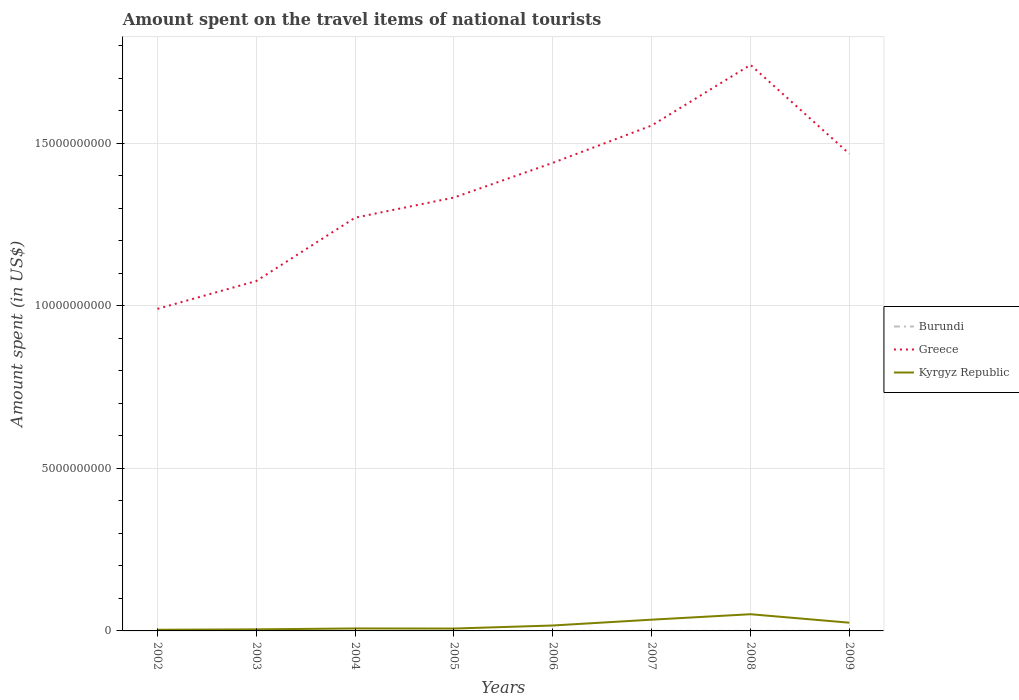Does the line corresponding to Kyrgyz Republic intersect with the line corresponding to Burundi?
Keep it short and to the point. No. Across all years, what is the maximum amount spent on the travel items of national tourists in Greece?
Your answer should be compact. 9.91e+09. In which year was the amount spent on the travel items of national tourists in Burundi maximum?
Your answer should be very brief. 2003. What is the total amount spent on the travel items of national tourists in Kyrgyz Republic in the graph?
Your response must be concise. 9.30e+07. What is the difference between the highest and the second highest amount spent on the travel items of national tourists in Burundi?
Offer a very short reply. 8.00e+05. Is the amount spent on the travel items of national tourists in Kyrgyz Republic strictly greater than the amount spent on the travel items of national tourists in Greece over the years?
Give a very brief answer. Yes. How many years are there in the graph?
Your answer should be compact. 8. Does the graph contain any zero values?
Provide a short and direct response. No. How are the legend labels stacked?
Make the answer very short. Vertical. What is the title of the graph?
Keep it short and to the point. Amount spent on the travel items of national tourists. Does "Cameroon" appear as one of the legend labels in the graph?
Give a very brief answer. No. What is the label or title of the X-axis?
Your answer should be very brief. Years. What is the label or title of the Y-axis?
Your response must be concise. Amount spent (in US$). What is the Amount spent (in US$) of Burundi in 2002?
Give a very brief answer. 1.10e+06. What is the Amount spent (in US$) in Greece in 2002?
Ensure brevity in your answer.  9.91e+09. What is the Amount spent (in US$) in Kyrgyz Republic in 2002?
Keep it short and to the point. 3.60e+07. What is the Amount spent (in US$) of Greece in 2003?
Provide a short and direct response. 1.08e+1. What is the Amount spent (in US$) of Kyrgyz Republic in 2003?
Offer a terse response. 4.80e+07. What is the Amount spent (in US$) of Burundi in 2004?
Your answer should be very brief. 1.20e+06. What is the Amount spent (in US$) of Greece in 2004?
Provide a short and direct response. 1.27e+1. What is the Amount spent (in US$) in Kyrgyz Republic in 2004?
Provide a succinct answer. 7.60e+07. What is the Amount spent (in US$) of Burundi in 2005?
Make the answer very short. 1.50e+06. What is the Amount spent (in US$) in Greece in 2005?
Your answer should be compact. 1.33e+1. What is the Amount spent (in US$) in Kyrgyz Republic in 2005?
Your response must be concise. 7.30e+07. What is the Amount spent (in US$) of Burundi in 2006?
Ensure brevity in your answer.  1.30e+06. What is the Amount spent (in US$) of Greece in 2006?
Give a very brief answer. 1.44e+1. What is the Amount spent (in US$) of Kyrgyz Republic in 2006?
Ensure brevity in your answer.  1.67e+08. What is the Amount spent (in US$) of Burundi in 2007?
Give a very brief answer. 1.30e+06. What is the Amount spent (in US$) of Greece in 2007?
Offer a very short reply. 1.56e+1. What is the Amount spent (in US$) of Kyrgyz Republic in 2007?
Offer a very short reply. 3.46e+08. What is the Amount spent (in US$) in Burundi in 2008?
Offer a terse response. 1.30e+06. What is the Amount spent (in US$) of Greece in 2008?
Make the answer very short. 1.74e+1. What is the Amount spent (in US$) of Kyrgyz Republic in 2008?
Your answer should be compact. 5.14e+08. What is the Amount spent (in US$) in Burundi in 2009?
Provide a succinct answer. 1.50e+06. What is the Amount spent (in US$) in Greece in 2009?
Ensure brevity in your answer.  1.47e+1. What is the Amount spent (in US$) of Kyrgyz Republic in 2009?
Make the answer very short. 2.53e+08. Across all years, what is the maximum Amount spent (in US$) of Burundi?
Offer a terse response. 1.50e+06. Across all years, what is the maximum Amount spent (in US$) of Greece?
Your answer should be compact. 1.74e+1. Across all years, what is the maximum Amount spent (in US$) in Kyrgyz Republic?
Offer a terse response. 5.14e+08. Across all years, what is the minimum Amount spent (in US$) of Greece?
Your answer should be compact. 9.91e+09. Across all years, what is the minimum Amount spent (in US$) in Kyrgyz Republic?
Your answer should be compact. 3.60e+07. What is the total Amount spent (in US$) of Burundi in the graph?
Offer a very short reply. 9.90e+06. What is the total Amount spent (in US$) of Greece in the graph?
Keep it short and to the point. 1.09e+11. What is the total Amount spent (in US$) in Kyrgyz Republic in the graph?
Provide a short and direct response. 1.51e+09. What is the difference between the Amount spent (in US$) of Burundi in 2002 and that in 2003?
Your answer should be compact. 4.00e+05. What is the difference between the Amount spent (in US$) of Greece in 2002 and that in 2003?
Provide a short and direct response. -8.57e+08. What is the difference between the Amount spent (in US$) in Kyrgyz Republic in 2002 and that in 2003?
Your answer should be compact. -1.20e+07. What is the difference between the Amount spent (in US$) of Greece in 2002 and that in 2004?
Keep it short and to the point. -2.81e+09. What is the difference between the Amount spent (in US$) in Kyrgyz Republic in 2002 and that in 2004?
Provide a short and direct response. -4.00e+07. What is the difference between the Amount spent (in US$) in Burundi in 2002 and that in 2005?
Keep it short and to the point. -4.00e+05. What is the difference between the Amount spent (in US$) in Greece in 2002 and that in 2005?
Offer a terse response. -3.42e+09. What is the difference between the Amount spent (in US$) of Kyrgyz Republic in 2002 and that in 2005?
Your response must be concise. -3.70e+07. What is the difference between the Amount spent (in US$) in Greece in 2002 and that in 2006?
Your response must be concise. -4.49e+09. What is the difference between the Amount spent (in US$) in Kyrgyz Republic in 2002 and that in 2006?
Provide a short and direct response. -1.31e+08. What is the difference between the Amount spent (in US$) in Greece in 2002 and that in 2007?
Your answer should be compact. -5.64e+09. What is the difference between the Amount spent (in US$) in Kyrgyz Republic in 2002 and that in 2007?
Provide a short and direct response. -3.10e+08. What is the difference between the Amount spent (in US$) of Burundi in 2002 and that in 2008?
Make the answer very short. -2.00e+05. What is the difference between the Amount spent (in US$) of Greece in 2002 and that in 2008?
Ensure brevity in your answer.  -7.51e+09. What is the difference between the Amount spent (in US$) of Kyrgyz Republic in 2002 and that in 2008?
Your response must be concise. -4.78e+08. What is the difference between the Amount spent (in US$) of Burundi in 2002 and that in 2009?
Offer a terse response. -4.00e+05. What is the difference between the Amount spent (in US$) in Greece in 2002 and that in 2009?
Keep it short and to the point. -4.77e+09. What is the difference between the Amount spent (in US$) in Kyrgyz Republic in 2002 and that in 2009?
Your response must be concise. -2.17e+08. What is the difference between the Amount spent (in US$) in Burundi in 2003 and that in 2004?
Offer a terse response. -5.00e+05. What is the difference between the Amount spent (in US$) in Greece in 2003 and that in 2004?
Your response must be concise. -1.95e+09. What is the difference between the Amount spent (in US$) of Kyrgyz Republic in 2003 and that in 2004?
Your response must be concise. -2.80e+07. What is the difference between the Amount spent (in US$) of Burundi in 2003 and that in 2005?
Your response must be concise. -8.00e+05. What is the difference between the Amount spent (in US$) of Greece in 2003 and that in 2005?
Provide a short and direct response. -2.57e+09. What is the difference between the Amount spent (in US$) in Kyrgyz Republic in 2003 and that in 2005?
Provide a succinct answer. -2.50e+07. What is the difference between the Amount spent (in US$) in Burundi in 2003 and that in 2006?
Provide a short and direct response. -6.00e+05. What is the difference between the Amount spent (in US$) of Greece in 2003 and that in 2006?
Give a very brief answer. -3.64e+09. What is the difference between the Amount spent (in US$) in Kyrgyz Republic in 2003 and that in 2006?
Give a very brief answer. -1.19e+08. What is the difference between the Amount spent (in US$) of Burundi in 2003 and that in 2007?
Your answer should be compact. -6.00e+05. What is the difference between the Amount spent (in US$) of Greece in 2003 and that in 2007?
Offer a very short reply. -4.78e+09. What is the difference between the Amount spent (in US$) in Kyrgyz Republic in 2003 and that in 2007?
Make the answer very short. -2.98e+08. What is the difference between the Amount spent (in US$) of Burundi in 2003 and that in 2008?
Your response must be concise. -6.00e+05. What is the difference between the Amount spent (in US$) in Greece in 2003 and that in 2008?
Make the answer very short. -6.65e+09. What is the difference between the Amount spent (in US$) of Kyrgyz Republic in 2003 and that in 2008?
Provide a succinct answer. -4.66e+08. What is the difference between the Amount spent (in US$) in Burundi in 2003 and that in 2009?
Provide a short and direct response. -8.00e+05. What is the difference between the Amount spent (in US$) of Greece in 2003 and that in 2009?
Your response must be concise. -3.92e+09. What is the difference between the Amount spent (in US$) in Kyrgyz Republic in 2003 and that in 2009?
Your answer should be very brief. -2.05e+08. What is the difference between the Amount spent (in US$) in Burundi in 2004 and that in 2005?
Make the answer very short. -3.00e+05. What is the difference between the Amount spent (in US$) of Greece in 2004 and that in 2005?
Make the answer very short. -6.19e+08. What is the difference between the Amount spent (in US$) in Burundi in 2004 and that in 2006?
Provide a short and direct response. -1.00e+05. What is the difference between the Amount spent (in US$) of Greece in 2004 and that in 2006?
Your answer should be compact. -1.69e+09. What is the difference between the Amount spent (in US$) in Kyrgyz Republic in 2004 and that in 2006?
Ensure brevity in your answer.  -9.10e+07. What is the difference between the Amount spent (in US$) of Burundi in 2004 and that in 2007?
Your answer should be compact. -1.00e+05. What is the difference between the Amount spent (in US$) of Greece in 2004 and that in 2007?
Offer a terse response. -2.84e+09. What is the difference between the Amount spent (in US$) of Kyrgyz Republic in 2004 and that in 2007?
Make the answer very short. -2.70e+08. What is the difference between the Amount spent (in US$) of Greece in 2004 and that in 2008?
Your response must be concise. -4.70e+09. What is the difference between the Amount spent (in US$) in Kyrgyz Republic in 2004 and that in 2008?
Your answer should be very brief. -4.38e+08. What is the difference between the Amount spent (in US$) of Greece in 2004 and that in 2009?
Your answer should be compact. -1.97e+09. What is the difference between the Amount spent (in US$) in Kyrgyz Republic in 2004 and that in 2009?
Keep it short and to the point. -1.77e+08. What is the difference between the Amount spent (in US$) in Burundi in 2005 and that in 2006?
Your answer should be compact. 2.00e+05. What is the difference between the Amount spent (in US$) of Greece in 2005 and that in 2006?
Your answer should be very brief. -1.07e+09. What is the difference between the Amount spent (in US$) of Kyrgyz Republic in 2005 and that in 2006?
Give a very brief answer. -9.40e+07. What is the difference between the Amount spent (in US$) in Burundi in 2005 and that in 2007?
Make the answer very short. 2.00e+05. What is the difference between the Amount spent (in US$) of Greece in 2005 and that in 2007?
Your response must be concise. -2.22e+09. What is the difference between the Amount spent (in US$) in Kyrgyz Republic in 2005 and that in 2007?
Give a very brief answer. -2.73e+08. What is the difference between the Amount spent (in US$) in Burundi in 2005 and that in 2008?
Give a very brief answer. 2.00e+05. What is the difference between the Amount spent (in US$) in Greece in 2005 and that in 2008?
Offer a very short reply. -4.08e+09. What is the difference between the Amount spent (in US$) in Kyrgyz Republic in 2005 and that in 2008?
Keep it short and to the point. -4.41e+08. What is the difference between the Amount spent (in US$) in Greece in 2005 and that in 2009?
Your answer should be compact. -1.35e+09. What is the difference between the Amount spent (in US$) in Kyrgyz Republic in 2005 and that in 2009?
Your answer should be very brief. -1.80e+08. What is the difference between the Amount spent (in US$) in Greece in 2006 and that in 2007?
Your answer should be compact. -1.15e+09. What is the difference between the Amount spent (in US$) in Kyrgyz Republic in 2006 and that in 2007?
Ensure brevity in your answer.  -1.79e+08. What is the difference between the Amount spent (in US$) of Burundi in 2006 and that in 2008?
Provide a short and direct response. 0. What is the difference between the Amount spent (in US$) in Greece in 2006 and that in 2008?
Offer a terse response. -3.01e+09. What is the difference between the Amount spent (in US$) of Kyrgyz Republic in 2006 and that in 2008?
Ensure brevity in your answer.  -3.47e+08. What is the difference between the Amount spent (in US$) of Greece in 2006 and that in 2009?
Your response must be concise. -2.79e+08. What is the difference between the Amount spent (in US$) of Kyrgyz Republic in 2006 and that in 2009?
Offer a very short reply. -8.60e+07. What is the difference between the Amount spent (in US$) of Greece in 2007 and that in 2008?
Provide a short and direct response. -1.87e+09. What is the difference between the Amount spent (in US$) in Kyrgyz Republic in 2007 and that in 2008?
Ensure brevity in your answer.  -1.68e+08. What is the difference between the Amount spent (in US$) of Burundi in 2007 and that in 2009?
Offer a very short reply. -2.00e+05. What is the difference between the Amount spent (in US$) in Greece in 2007 and that in 2009?
Your response must be concise. 8.69e+08. What is the difference between the Amount spent (in US$) of Kyrgyz Republic in 2007 and that in 2009?
Your answer should be very brief. 9.30e+07. What is the difference between the Amount spent (in US$) in Burundi in 2008 and that in 2009?
Offer a very short reply. -2.00e+05. What is the difference between the Amount spent (in US$) in Greece in 2008 and that in 2009?
Give a very brief answer. 2.74e+09. What is the difference between the Amount spent (in US$) in Kyrgyz Republic in 2008 and that in 2009?
Make the answer very short. 2.61e+08. What is the difference between the Amount spent (in US$) of Burundi in 2002 and the Amount spent (in US$) of Greece in 2003?
Give a very brief answer. -1.08e+1. What is the difference between the Amount spent (in US$) in Burundi in 2002 and the Amount spent (in US$) in Kyrgyz Republic in 2003?
Your answer should be very brief. -4.69e+07. What is the difference between the Amount spent (in US$) in Greece in 2002 and the Amount spent (in US$) in Kyrgyz Republic in 2003?
Provide a short and direct response. 9.86e+09. What is the difference between the Amount spent (in US$) in Burundi in 2002 and the Amount spent (in US$) in Greece in 2004?
Ensure brevity in your answer.  -1.27e+1. What is the difference between the Amount spent (in US$) of Burundi in 2002 and the Amount spent (in US$) of Kyrgyz Republic in 2004?
Keep it short and to the point. -7.49e+07. What is the difference between the Amount spent (in US$) in Greece in 2002 and the Amount spent (in US$) in Kyrgyz Republic in 2004?
Give a very brief answer. 9.83e+09. What is the difference between the Amount spent (in US$) of Burundi in 2002 and the Amount spent (in US$) of Greece in 2005?
Make the answer very short. -1.33e+1. What is the difference between the Amount spent (in US$) of Burundi in 2002 and the Amount spent (in US$) of Kyrgyz Republic in 2005?
Your answer should be compact. -7.19e+07. What is the difference between the Amount spent (in US$) of Greece in 2002 and the Amount spent (in US$) of Kyrgyz Republic in 2005?
Your response must be concise. 9.84e+09. What is the difference between the Amount spent (in US$) in Burundi in 2002 and the Amount spent (in US$) in Greece in 2006?
Provide a short and direct response. -1.44e+1. What is the difference between the Amount spent (in US$) in Burundi in 2002 and the Amount spent (in US$) in Kyrgyz Republic in 2006?
Keep it short and to the point. -1.66e+08. What is the difference between the Amount spent (in US$) in Greece in 2002 and the Amount spent (in US$) in Kyrgyz Republic in 2006?
Offer a terse response. 9.74e+09. What is the difference between the Amount spent (in US$) of Burundi in 2002 and the Amount spent (in US$) of Greece in 2007?
Make the answer very short. -1.55e+1. What is the difference between the Amount spent (in US$) in Burundi in 2002 and the Amount spent (in US$) in Kyrgyz Republic in 2007?
Offer a very short reply. -3.45e+08. What is the difference between the Amount spent (in US$) in Greece in 2002 and the Amount spent (in US$) in Kyrgyz Republic in 2007?
Provide a succinct answer. 9.56e+09. What is the difference between the Amount spent (in US$) of Burundi in 2002 and the Amount spent (in US$) of Greece in 2008?
Provide a short and direct response. -1.74e+1. What is the difference between the Amount spent (in US$) of Burundi in 2002 and the Amount spent (in US$) of Kyrgyz Republic in 2008?
Give a very brief answer. -5.13e+08. What is the difference between the Amount spent (in US$) in Greece in 2002 and the Amount spent (in US$) in Kyrgyz Republic in 2008?
Keep it short and to the point. 9.40e+09. What is the difference between the Amount spent (in US$) of Burundi in 2002 and the Amount spent (in US$) of Greece in 2009?
Keep it short and to the point. -1.47e+1. What is the difference between the Amount spent (in US$) of Burundi in 2002 and the Amount spent (in US$) of Kyrgyz Republic in 2009?
Ensure brevity in your answer.  -2.52e+08. What is the difference between the Amount spent (in US$) of Greece in 2002 and the Amount spent (in US$) of Kyrgyz Republic in 2009?
Offer a very short reply. 9.66e+09. What is the difference between the Amount spent (in US$) in Burundi in 2003 and the Amount spent (in US$) in Greece in 2004?
Keep it short and to the point. -1.27e+1. What is the difference between the Amount spent (in US$) in Burundi in 2003 and the Amount spent (in US$) in Kyrgyz Republic in 2004?
Your answer should be very brief. -7.53e+07. What is the difference between the Amount spent (in US$) in Greece in 2003 and the Amount spent (in US$) in Kyrgyz Republic in 2004?
Keep it short and to the point. 1.07e+1. What is the difference between the Amount spent (in US$) of Burundi in 2003 and the Amount spent (in US$) of Greece in 2005?
Your answer should be very brief. -1.33e+1. What is the difference between the Amount spent (in US$) in Burundi in 2003 and the Amount spent (in US$) in Kyrgyz Republic in 2005?
Give a very brief answer. -7.23e+07. What is the difference between the Amount spent (in US$) in Greece in 2003 and the Amount spent (in US$) in Kyrgyz Republic in 2005?
Give a very brief answer. 1.07e+1. What is the difference between the Amount spent (in US$) of Burundi in 2003 and the Amount spent (in US$) of Greece in 2006?
Offer a very short reply. -1.44e+1. What is the difference between the Amount spent (in US$) of Burundi in 2003 and the Amount spent (in US$) of Kyrgyz Republic in 2006?
Provide a short and direct response. -1.66e+08. What is the difference between the Amount spent (in US$) in Greece in 2003 and the Amount spent (in US$) in Kyrgyz Republic in 2006?
Your answer should be compact. 1.06e+1. What is the difference between the Amount spent (in US$) in Burundi in 2003 and the Amount spent (in US$) in Greece in 2007?
Make the answer very short. -1.55e+1. What is the difference between the Amount spent (in US$) of Burundi in 2003 and the Amount spent (in US$) of Kyrgyz Republic in 2007?
Offer a terse response. -3.45e+08. What is the difference between the Amount spent (in US$) in Greece in 2003 and the Amount spent (in US$) in Kyrgyz Republic in 2007?
Provide a short and direct response. 1.04e+1. What is the difference between the Amount spent (in US$) in Burundi in 2003 and the Amount spent (in US$) in Greece in 2008?
Give a very brief answer. -1.74e+1. What is the difference between the Amount spent (in US$) in Burundi in 2003 and the Amount spent (in US$) in Kyrgyz Republic in 2008?
Provide a short and direct response. -5.13e+08. What is the difference between the Amount spent (in US$) in Greece in 2003 and the Amount spent (in US$) in Kyrgyz Republic in 2008?
Your answer should be very brief. 1.03e+1. What is the difference between the Amount spent (in US$) of Burundi in 2003 and the Amount spent (in US$) of Greece in 2009?
Provide a short and direct response. -1.47e+1. What is the difference between the Amount spent (in US$) in Burundi in 2003 and the Amount spent (in US$) in Kyrgyz Republic in 2009?
Your answer should be very brief. -2.52e+08. What is the difference between the Amount spent (in US$) in Greece in 2003 and the Amount spent (in US$) in Kyrgyz Republic in 2009?
Ensure brevity in your answer.  1.05e+1. What is the difference between the Amount spent (in US$) in Burundi in 2004 and the Amount spent (in US$) in Greece in 2005?
Offer a very short reply. -1.33e+1. What is the difference between the Amount spent (in US$) in Burundi in 2004 and the Amount spent (in US$) in Kyrgyz Republic in 2005?
Provide a succinct answer. -7.18e+07. What is the difference between the Amount spent (in US$) of Greece in 2004 and the Amount spent (in US$) of Kyrgyz Republic in 2005?
Keep it short and to the point. 1.26e+1. What is the difference between the Amount spent (in US$) of Burundi in 2004 and the Amount spent (in US$) of Greece in 2006?
Ensure brevity in your answer.  -1.44e+1. What is the difference between the Amount spent (in US$) in Burundi in 2004 and the Amount spent (in US$) in Kyrgyz Republic in 2006?
Provide a short and direct response. -1.66e+08. What is the difference between the Amount spent (in US$) in Greece in 2004 and the Amount spent (in US$) in Kyrgyz Republic in 2006?
Offer a terse response. 1.25e+1. What is the difference between the Amount spent (in US$) in Burundi in 2004 and the Amount spent (in US$) in Greece in 2007?
Provide a succinct answer. -1.55e+1. What is the difference between the Amount spent (in US$) of Burundi in 2004 and the Amount spent (in US$) of Kyrgyz Republic in 2007?
Your response must be concise. -3.45e+08. What is the difference between the Amount spent (in US$) of Greece in 2004 and the Amount spent (in US$) of Kyrgyz Republic in 2007?
Offer a terse response. 1.24e+1. What is the difference between the Amount spent (in US$) of Burundi in 2004 and the Amount spent (in US$) of Greece in 2008?
Offer a very short reply. -1.74e+1. What is the difference between the Amount spent (in US$) in Burundi in 2004 and the Amount spent (in US$) in Kyrgyz Republic in 2008?
Provide a short and direct response. -5.13e+08. What is the difference between the Amount spent (in US$) in Greece in 2004 and the Amount spent (in US$) in Kyrgyz Republic in 2008?
Give a very brief answer. 1.22e+1. What is the difference between the Amount spent (in US$) of Burundi in 2004 and the Amount spent (in US$) of Greece in 2009?
Give a very brief answer. -1.47e+1. What is the difference between the Amount spent (in US$) of Burundi in 2004 and the Amount spent (in US$) of Kyrgyz Republic in 2009?
Your answer should be very brief. -2.52e+08. What is the difference between the Amount spent (in US$) of Greece in 2004 and the Amount spent (in US$) of Kyrgyz Republic in 2009?
Provide a short and direct response. 1.25e+1. What is the difference between the Amount spent (in US$) of Burundi in 2005 and the Amount spent (in US$) of Greece in 2006?
Provide a succinct answer. -1.44e+1. What is the difference between the Amount spent (in US$) in Burundi in 2005 and the Amount spent (in US$) in Kyrgyz Republic in 2006?
Your answer should be very brief. -1.66e+08. What is the difference between the Amount spent (in US$) of Greece in 2005 and the Amount spent (in US$) of Kyrgyz Republic in 2006?
Provide a short and direct response. 1.32e+1. What is the difference between the Amount spent (in US$) in Burundi in 2005 and the Amount spent (in US$) in Greece in 2007?
Offer a very short reply. -1.55e+1. What is the difference between the Amount spent (in US$) of Burundi in 2005 and the Amount spent (in US$) of Kyrgyz Republic in 2007?
Give a very brief answer. -3.44e+08. What is the difference between the Amount spent (in US$) of Greece in 2005 and the Amount spent (in US$) of Kyrgyz Republic in 2007?
Your response must be concise. 1.30e+1. What is the difference between the Amount spent (in US$) of Burundi in 2005 and the Amount spent (in US$) of Greece in 2008?
Your answer should be compact. -1.74e+1. What is the difference between the Amount spent (in US$) in Burundi in 2005 and the Amount spent (in US$) in Kyrgyz Republic in 2008?
Your response must be concise. -5.12e+08. What is the difference between the Amount spent (in US$) of Greece in 2005 and the Amount spent (in US$) of Kyrgyz Republic in 2008?
Your answer should be very brief. 1.28e+1. What is the difference between the Amount spent (in US$) of Burundi in 2005 and the Amount spent (in US$) of Greece in 2009?
Your response must be concise. -1.47e+1. What is the difference between the Amount spent (in US$) in Burundi in 2005 and the Amount spent (in US$) in Kyrgyz Republic in 2009?
Your answer should be compact. -2.52e+08. What is the difference between the Amount spent (in US$) in Greece in 2005 and the Amount spent (in US$) in Kyrgyz Republic in 2009?
Your answer should be compact. 1.31e+1. What is the difference between the Amount spent (in US$) in Burundi in 2006 and the Amount spent (in US$) in Greece in 2007?
Your answer should be very brief. -1.55e+1. What is the difference between the Amount spent (in US$) of Burundi in 2006 and the Amount spent (in US$) of Kyrgyz Republic in 2007?
Give a very brief answer. -3.45e+08. What is the difference between the Amount spent (in US$) in Greece in 2006 and the Amount spent (in US$) in Kyrgyz Republic in 2007?
Your response must be concise. 1.41e+1. What is the difference between the Amount spent (in US$) of Burundi in 2006 and the Amount spent (in US$) of Greece in 2008?
Your answer should be compact. -1.74e+1. What is the difference between the Amount spent (in US$) of Burundi in 2006 and the Amount spent (in US$) of Kyrgyz Republic in 2008?
Your answer should be compact. -5.13e+08. What is the difference between the Amount spent (in US$) in Greece in 2006 and the Amount spent (in US$) in Kyrgyz Republic in 2008?
Offer a terse response. 1.39e+1. What is the difference between the Amount spent (in US$) in Burundi in 2006 and the Amount spent (in US$) in Greece in 2009?
Provide a short and direct response. -1.47e+1. What is the difference between the Amount spent (in US$) of Burundi in 2006 and the Amount spent (in US$) of Kyrgyz Republic in 2009?
Offer a terse response. -2.52e+08. What is the difference between the Amount spent (in US$) of Greece in 2006 and the Amount spent (in US$) of Kyrgyz Republic in 2009?
Give a very brief answer. 1.41e+1. What is the difference between the Amount spent (in US$) of Burundi in 2007 and the Amount spent (in US$) of Greece in 2008?
Offer a very short reply. -1.74e+1. What is the difference between the Amount spent (in US$) in Burundi in 2007 and the Amount spent (in US$) in Kyrgyz Republic in 2008?
Keep it short and to the point. -5.13e+08. What is the difference between the Amount spent (in US$) of Greece in 2007 and the Amount spent (in US$) of Kyrgyz Republic in 2008?
Provide a short and direct response. 1.50e+1. What is the difference between the Amount spent (in US$) of Burundi in 2007 and the Amount spent (in US$) of Greece in 2009?
Make the answer very short. -1.47e+1. What is the difference between the Amount spent (in US$) in Burundi in 2007 and the Amount spent (in US$) in Kyrgyz Republic in 2009?
Make the answer very short. -2.52e+08. What is the difference between the Amount spent (in US$) of Greece in 2007 and the Amount spent (in US$) of Kyrgyz Republic in 2009?
Provide a short and direct response. 1.53e+1. What is the difference between the Amount spent (in US$) in Burundi in 2008 and the Amount spent (in US$) in Greece in 2009?
Ensure brevity in your answer.  -1.47e+1. What is the difference between the Amount spent (in US$) in Burundi in 2008 and the Amount spent (in US$) in Kyrgyz Republic in 2009?
Offer a terse response. -2.52e+08. What is the difference between the Amount spent (in US$) of Greece in 2008 and the Amount spent (in US$) of Kyrgyz Republic in 2009?
Offer a terse response. 1.72e+1. What is the average Amount spent (in US$) in Burundi per year?
Your response must be concise. 1.24e+06. What is the average Amount spent (in US$) of Greece per year?
Your response must be concise. 1.36e+1. What is the average Amount spent (in US$) of Kyrgyz Republic per year?
Your response must be concise. 1.89e+08. In the year 2002, what is the difference between the Amount spent (in US$) of Burundi and Amount spent (in US$) of Greece?
Your answer should be very brief. -9.91e+09. In the year 2002, what is the difference between the Amount spent (in US$) of Burundi and Amount spent (in US$) of Kyrgyz Republic?
Provide a short and direct response. -3.49e+07. In the year 2002, what is the difference between the Amount spent (in US$) of Greece and Amount spent (in US$) of Kyrgyz Republic?
Ensure brevity in your answer.  9.87e+09. In the year 2003, what is the difference between the Amount spent (in US$) in Burundi and Amount spent (in US$) in Greece?
Your answer should be compact. -1.08e+1. In the year 2003, what is the difference between the Amount spent (in US$) of Burundi and Amount spent (in US$) of Kyrgyz Republic?
Make the answer very short. -4.73e+07. In the year 2003, what is the difference between the Amount spent (in US$) of Greece and Amount spent (in US$) of Kyrgyz Republic?
Your answer should be compact. 1.07e+1. In the year 2004, what is the difference between the Amount spent (in US$) of Burundi and Amount spent (in US$) of Greece?
Your response must be concise. -1.27e+1. In the year 2004, what is the difference between the Amount spent (in US$) in Burundi and Amount spent (in US$) in Kyrgyz Republic?
Provide a short and direct response. -7.48e+07. In the year 2004, what is the difference between the Amount spent (in US$) in Greece and Amount spent (in US$) in Kyrgyz Republic?
Ensure brevity in your answer.  1.26e+1. In the year 2005, what is the difference between the Amount spent (in US$) in Burundi and Amount spent (in US$) in Greece?
Your answer should be compact. -1.33e+1. In the year 2005, what is the difference between the Amount spent (in US$) of Burundi and Amount spent (in US$) of Kyrgyz Republic?
Give a very brief answer. -7.15e+07. In the year 2005, what is the difference between the Amount spent (in US$) in Greece and Amount spent (in US$) in Kyrgyz Republic?
Give a very brief answer. 1.33e+1. In the year 2006, what is the difference between the Amount spent (in US$) in Burundi and Amount spent (in US$) in Greece?
Give a very brief answer. -1.44e+1. In the year 2006, what is the difference between the Amount spent (in US$) of Burundi and Amount spent (in US$) of Kyrgyz Republic?
Make the answer very short. -1.66e+08. In the year 2006, what is the difference between the Amount spent (in US$) of Greece and Amount spent (in US$) of Kyrgyz Republic?
Offer a very short reply. 1.42e+1. In the year 2007, what is the difference between the Amount spent (in US$) in Burundi and Amount spent (in US$) in Greece?
Your response must be concise. -1.55e+1. In the year 2007, what is the difference between the Amount spent (in US$) of Burundi and Amount spent (in US$) of Kyrgyz Republic?
Make the answer very short. -3.45e+08. In the year 2007, what is the difference between the Amount spent (in US$) in Greece and Amount spent (in US$) in Kyrgyz Republic?
Ensure brevity in your answer.  1.52e+1. In the year 2008, what is the difference between the Amount spent (in US$) in Burundi and Amount spent (in US$) in Greece?
Make the answer very short. -1.74e+1. In the year 2008, what is the difference between the Amount spent (in US$) of Burundi and Amount spent (in US$) of Kyrgyz Republic?
Provide a short and direct response. -5.13e+08. In the year 2008, what is the difference between the Amount spent (in US$) in Greece and Amount spent (in US$) in Kyrgyz Republic?
Offer a very short reply. 1.69e+1. In the year 2009, what is the difference between the Amount spent (in US$) in Burundi and Amount spent (in US$) in Greece?
Your response must be concise. -1.47e+1. In the year 2009, what is the difference between the Amount spent (in US$) of Burundi and Amount spent (in US$) of Kyrgyz Republic?
Provide a short and direct response. -2.52e+08. In the year 2009, what is the difference between the Amount spent (in US$) of Greece and Amount spent (in US$) of Kyrgyz Republic?
Your answer should be compact. 1.44e+1. What is the ratio of the Amount spent (in US$) of Burundi in 2002 to that in 2003?
Your answer should be very brief. 1.57. What is the ratio of the Amount spent (in US$) of Greece in 2002 to that in 2003?
Offer a very short reply. 0.92. What is the ratio of the Amount spent (in US$) of Kyrgyz Republic in 2002 to that in 2003?
Ensure brevity in your answer.  0.75. What is the ratio of the Amount spent (in US$) in Greece in 2002 to that in 2004?
Make the answer very short. 0.78. What is the ratio of the Amount spent (in US$) in Kyrgyz Republic in 2002 to that in 2004?
Your response must be concise. 0.47. What is the ratio of the Amount spent (in US$) of Burundi in 2002 to that in 2005?
Ensure brevity in your answer.  0.73. What is the ratio of the Amount spent (in US$) in Greece in 2002 to that in 2005?
Provide a succinct answer. 0.74. What is the ratio of the Amount spent (in US$) of Kyrgyz Republic in 2002 to that in 2005?
Make the answer very short. 0.49. What is the ratio of the Amount spent (in US$) in Burundi in 2002 to that in 2006?
Keep it short and to the point. 0.85. What is the ratio of the Amount spent (in US$) in Greece in 2002 to that in 2006?
Offer a terse response. 0.69. What is the ratio of the Amount spent (in US$) in Kyrgyz Republic in 2002 to that in 2006?
Offer a very short reply. 0.22. What is the ratio of the Amount spent (in US$) in Burundi in 2002 to that in 2007?
Keep it short and to the point. 0.85. What is the ratio of the Amount spent (in US$) of Greece in 2002 to that in 2007?
Your answer should be compact. 0.64. What is the ratio of the Amount spent (in US$) of Kyrgyz Republic in 2002 to that in 2007?
Offer a terse response. 0.1. What is the ratio of the Amount spent (in US$) of Burundi in 2002 to that in 2008?
Offer a very short reply. 0.85. What is the ratio of the Amount spent (in US$) in Greece in 2002 to that in 2008?
Make the answer very short. 0.57. What is the ratio of the Amount spent (in US$) of Kyrgyz Republic in 2002 to that in 2008?
Provide a short and direct response. 0.07. What is the ratio of the Amount spent (in US$) of Burundi in 2002 to that in 2009?
Offer a very short reply. 0.73. What is the ratio of the Amount spent (in US$) of Greece in 2002 to that in 2009?
Keep it short and to the point. 0.68. What is the ratio of the Amount spent (in US$) in Kyrgyz Republic in 2002 to that in 2009?
Give a very brief answer. 0.14. What is the ratio of the Amount spent (in US$) in Burundi in 2003 to that in 2004?
Make the answer very short. 0.58. What is the ratio of the Amount spent (in US$) in Greece in 2003 to that in 2004?
Offer a very short reply. 0.85. What is the ratio of the Amount spent (in US$) in Kyrgyz Republic in 2003 to that in 2004?
Keep it short and to the point. 0.63. What is the ratio of the Amount spent (in US$) of Burundi in 2003 to that in 2005?
Your response must be concise. 0.47. What is the ratio of the Amount spent (in US$) of Greece in 2003 to that in 2005?
Give a very brief answer. 0.81. What is the ratio of the Amount spent (in US$) of Kyrgyz Republic in 2003 to that in 2005?
Give a very brief answer. 0.66. What is the ratio of the Amount spent (in US$) of Burundi in 2003 to that in 2006?
Provide a succinct answer. 0.54. What is the ratio of the Amount spent (in US$) in Greece in 2003 to that in 2006?
Your answer should be very brief. 0.75. What is the ratio of the Amount spent (in US$) of Kyrgyz Republic in 2003 to that in 2006?
Provide a succinct answer. 0.29. What is the ratio of the Amount spent (in US$) of Burundi in 2003 to that in 2007?
Provide a succinct answer. 0.54. What is the ratio of the Amount spent (in US$) in Greece in 2003 to that in 2007?
Make the answer very short. 0.69. What is the ratio of the Amount spent (in US$) of Kyrgyz Republic in 2003 to that in 2007?
Your response must be concise. 0.14. What is the ratio of the Amount spent (in US$) of Burundi in 2003 to that in 2008?
Your response must be concise. 0.54. What is the ratio of the Amount spent (in US$) in Greece in 2003 to that in 2008?
Your response must be concise. 0.62. What is the ratio of the Amount spent (in US$) of Kyrgyz Republic in 2003 to that in 2008?
Offer a terse response. 0.09. What is the ratio of the Amount spent (in US$) of Burundi in 2003 to that in 2009?
Make the answer very short. 0.47. What is the ratio of the Amount spent (in US$) in Greece in 2003 to that in 2009?
Offer a very short reply. 0.73. What is the ratio of the Amount spent (in US$) of Kyrgyz Republic in 2003 to that in 2009?
Give a very brief answer. 0.19. What is the ratio of the Amount spent (in US$) in Greece in 2004 to that in 2005?
Provide a short and direct response. 0.95. What is the ratio of the Amount spent (in US$) in Kyrgyz Republic in 2004 to that in 2005?
Offer a very short reply. 1.04. What is the ratio of the Amount spent (in US$) in Burundi in 2004 to that in 2006?
Provide a succinct answer. 0.92. What is the ratio of the Amount spent (in US$) of Greece in 2004 to that in 2006?
Give a very brief answer. 0.88. What is the ratio of the Amount spent (in US$) of Kyrgyz Republic in 2004 to that in 2006?
Offer a very short reply. 0.46. What is the ratio of the Amount spent (in US$) in Burundi in 2004 to that in 2007?
Your response must be concise. 0.92. What is the ratio of the Amount spent (in US$) in Greece in 2004 to that in 2007?
Provide a succinct answer. 0.82. What is the ratio of the Amount spent (in US$) in Kyrgyz Republic in 2004 to that in 2007?
Ensure brevity in your answer.  0.22. What is the ratio of the Amount spent (in US$) of Greece in 2004 to that in 2008?
Keep it short and to the point. 0.73. What is the ratio of the Amount spent (in US$) of Kyrgyz Republic in 2004 to that in 2008?
Provide a short and direct response. 0.15. What is the ratio of the Amount spent (in US$) of Greece in 2004 to that in 2009?
Ensure brevity in your answer.  0.87. What is the ratio of the Amount spent (in US$) in Kyrgyz Republic in 2004 to that in 2009?
Your response must be concise. 0.3. What is the ratio of the Amount spent (in US$) of Burundi in 2005 to that in 2006?
Ensure brevity in your answer.  1.15. What is the ratio of the Amount spent (in US$) of Greece in 2005 to that in 2006?
Your response must be concise. 0.93. What is the ratio of the Amount spent (in US$) in Kyrgyz Republic in 2005 to that in 2006?
Keep it short and to the point. 0.44. What is the ratio of the Amount spent (in US$) of Burundi in 2005 to that in 2007?
Make the answer very short. 1.15. What is the ratio of the Amount spent (in US$) in Greece in 2005 to that in 2007?
Provide a succinct answer. 0.86. What is the ratio of the Amount spent (in US$) in Kyrgyz Republic in 2005 to that in 2007?
Your response must be concise. 0.21. What is the ratio of the Amount spent (in US$) in Burundi in 2005 to that in 2008?
Offer a terse response. 1.15. What is the ratio of the Amount spent (in US$) of Greece in 2005 to that in 2008?
Your answer should be very brief. 0.77. What is the ratio of the Amount spent (in US$) in Kyrgyz Republic in 2005 to that in 2008?
Give a very brief answer. 0.14. What is the ratio of the Amount spent (in US$) in Burundi in 2005 to that in 2009?
Your answer should be compact. 1. What is the ratio of the Amount spent (in US$) of Greece in 2005 to that in 2009?
Provide a succinct answer. 0.91. What is the ratio of the Amount spent (in US$) in Kyrgyz Republic in 2005 to that in 2009?
Give a very brief answer. 0.29. What is the ratio of the Amount spent (in US$) of Greece in 2006 to that in 2007?
Make the answer very short. 0.93. What is the ratio of the Amount spent (in US$) of Kyrgyz Republic in 2006 to that in 2007?
Offer a terse response. 0.48. What is the ratio of the Amount spent (in US$) of Greece in 2006 to that in 2008?
Your response must be concise. 0.83. What is the ratio of the Amount spent (in US$) of Kyrgyz Republic in 2006 to that in 2008?
Give a very brief answer. 0.32. What is the ratio of the Amount spent (in US$) of Burundi in 2006 to that in 2009?
Your answer should be compact. 0.87. What is the ratio of the Amount spent (in US$) in Kyrgyz Republic in 2006 to that in 2009?
Provide a succinct answer. 0.66. What is the ratio of the Amount spent (in US$) of Greece in 2007 to that in 2008?
Your answer should be compact. 0.89. What is the ratio of the Amount spent (in US$) of Kyrgyz Republic in 2007 to that in 2008?
Offer a very short reply. 0.67. What is the ratio of the Amount spent (in US$) of Burundi in 2007 to that in 2009?
Keep it short and to the point. 0.87. What is the ratio of the Amount spent (in US$) of Greece in 2007 to that in 2009?
Give a very brief answer. 1.06. What is the ratio of the Amount spent (in US$) in Kyrgyz Republic in 2007 to that in 2009?
Provide a succinct answer. 1.37. What is the ratio of the Amount spent (in US$) in Burundi in 2008 to that in 2009?
Offer a terse response. 0.87. What is the ratio of the Amount spent (in US$) of Greece in 2008 to that in 2009?
Your response must be concise. 1.19. What is the ratio of the Amount spent (in US$) in Kyrgyz Republic in 2008 to that in 2009?
Provide a short and direct response. 2.03. What is the difference between the highest and the second highest Amount spent (in US$) in Burundi?
Your response must be concise. 0. What is the difference between the highest and the second highest Amount spent (in US$) in Greece?
Keep it short and to the point. 1.87e+09. What is the difference between the highest and the second highest Amount spent (in US$) in Kyrgyz Republic?
Your response must be concise. 1.68e+08. What is the difference between the highest and the lowest Amount spent (in US$) in Greece?
Your answer should be compact. 7.51e+09. What is the difference between the highest and the lowest Amount spent (in US$) of Kyrgyz Republic?
Offer a very short reply. 4.78e+08. 